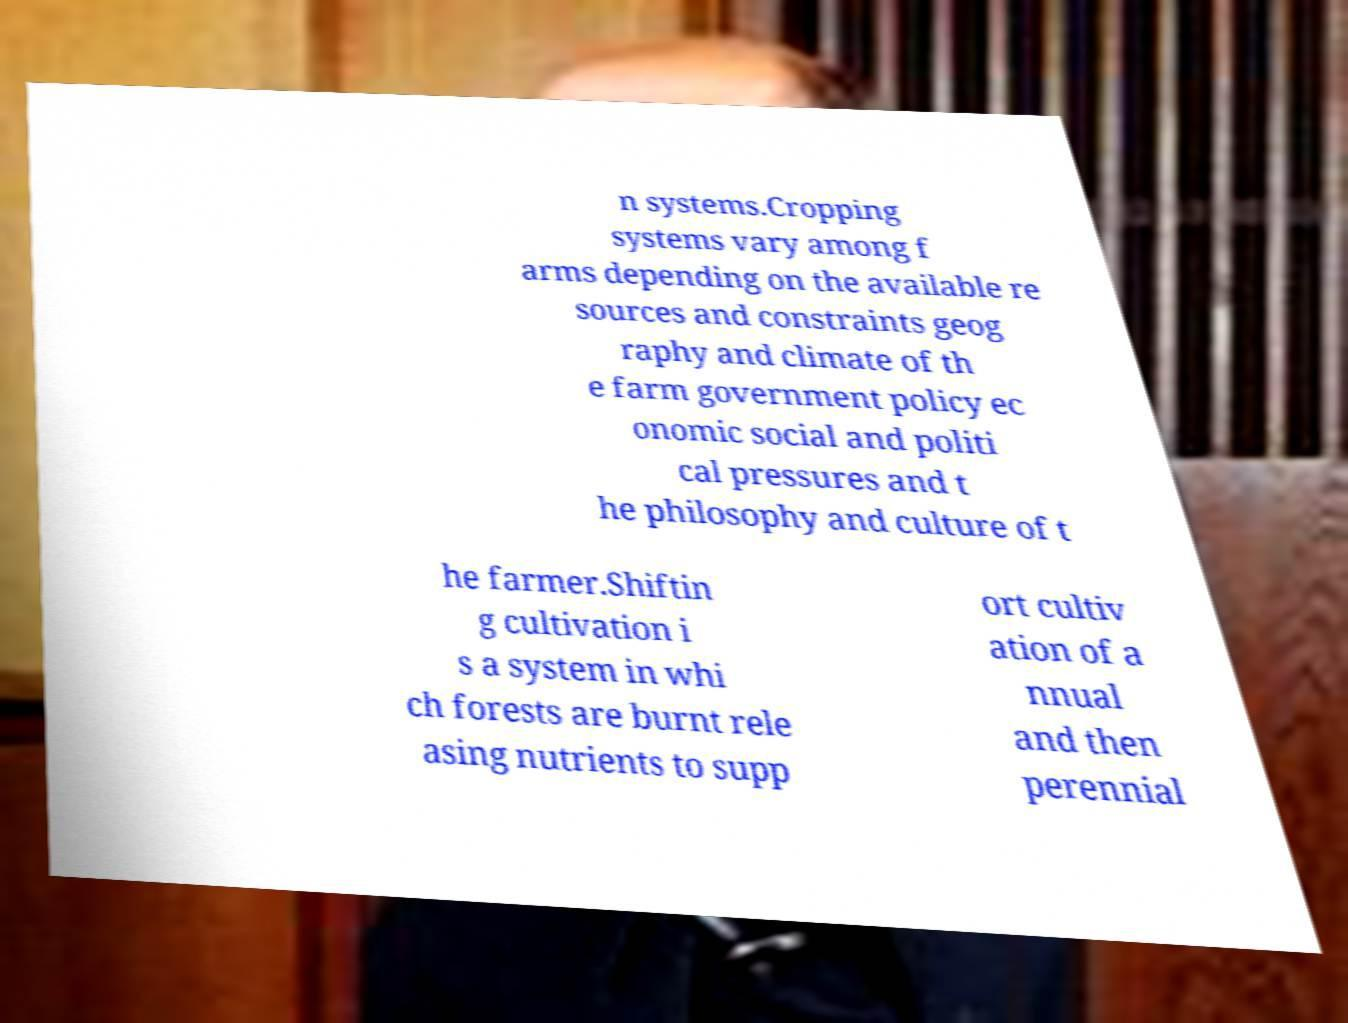Can you accurately transcribe the text from the provided image for me? n systems.Cropping systems vary among f arms depending on the available re sources and constraints geog raphy and climate of th e farm government policy ec onomic social and politi cal pressures and t he philosophy and culture of t he farmer.Shiftin g cultivation i s a system in whi ch forests are burnt rele asing nutrients to supp ort cultiv ation of a nnual and then perennial 